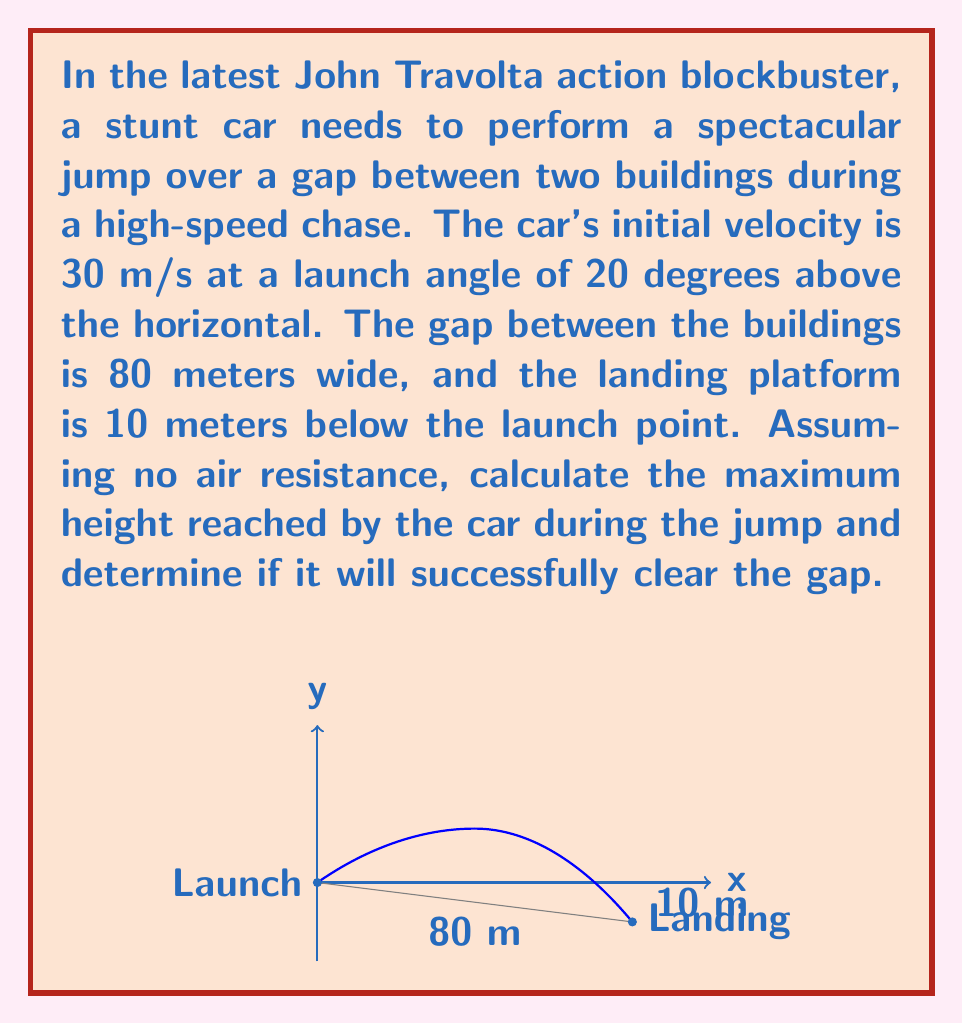What is the answer to this math problem? Let's approach this problem step-by-step using the equations of motion for projectile motion:

1) First, let's identify the given information:
   - Initial velocity, $v_0 = 30$ m/s
   - Launch angle, $\theta = 20°$
   - Horizontal distance to cover, $x = 80$ m
   - Vertical displacement, $y = -10$ m
   - Acceleration due to gravity, $g = 9.8$ m/s²

2) To find the maximum height, we need to use the equation:
   $$y_{max} = \frac{(v_0 \sin \theta)^2}{2g}$$

   Plugging in the values:
   $$y_{max} = \frac{(30 \sin 20°)^2}{2(9.8)} = 2.64\text{ m}$$

3) To determine if the car will clear the gap, we need to calculate the time of flight and the horizontal distance covered.

4) Time of flight can be calculated using:
   $$t = \frac{2v_0 \sin \theta}{g}$$

   $$t = \frac{2(30) \sin 20°}{9.8} = 2.08\text{ s}$$

5) Now, let's calculate the horizontal distance covered:
   $$x = v_0 \cos \theta \cdot t$$
   $$x = 30 \cos 20° \cdot 2.08 = 58.6\text{ m}$$

6) The car will travel 58.6 meters horizontally, which is less than the required 80 meters.
Answer: Maximum height: 2.64 m. The car will not clear the 80 m gap. 